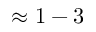Convert formula to latex. <formula><loc_0><loc_0><loc_500><loc_500>\approx 1 - 3</formula> 